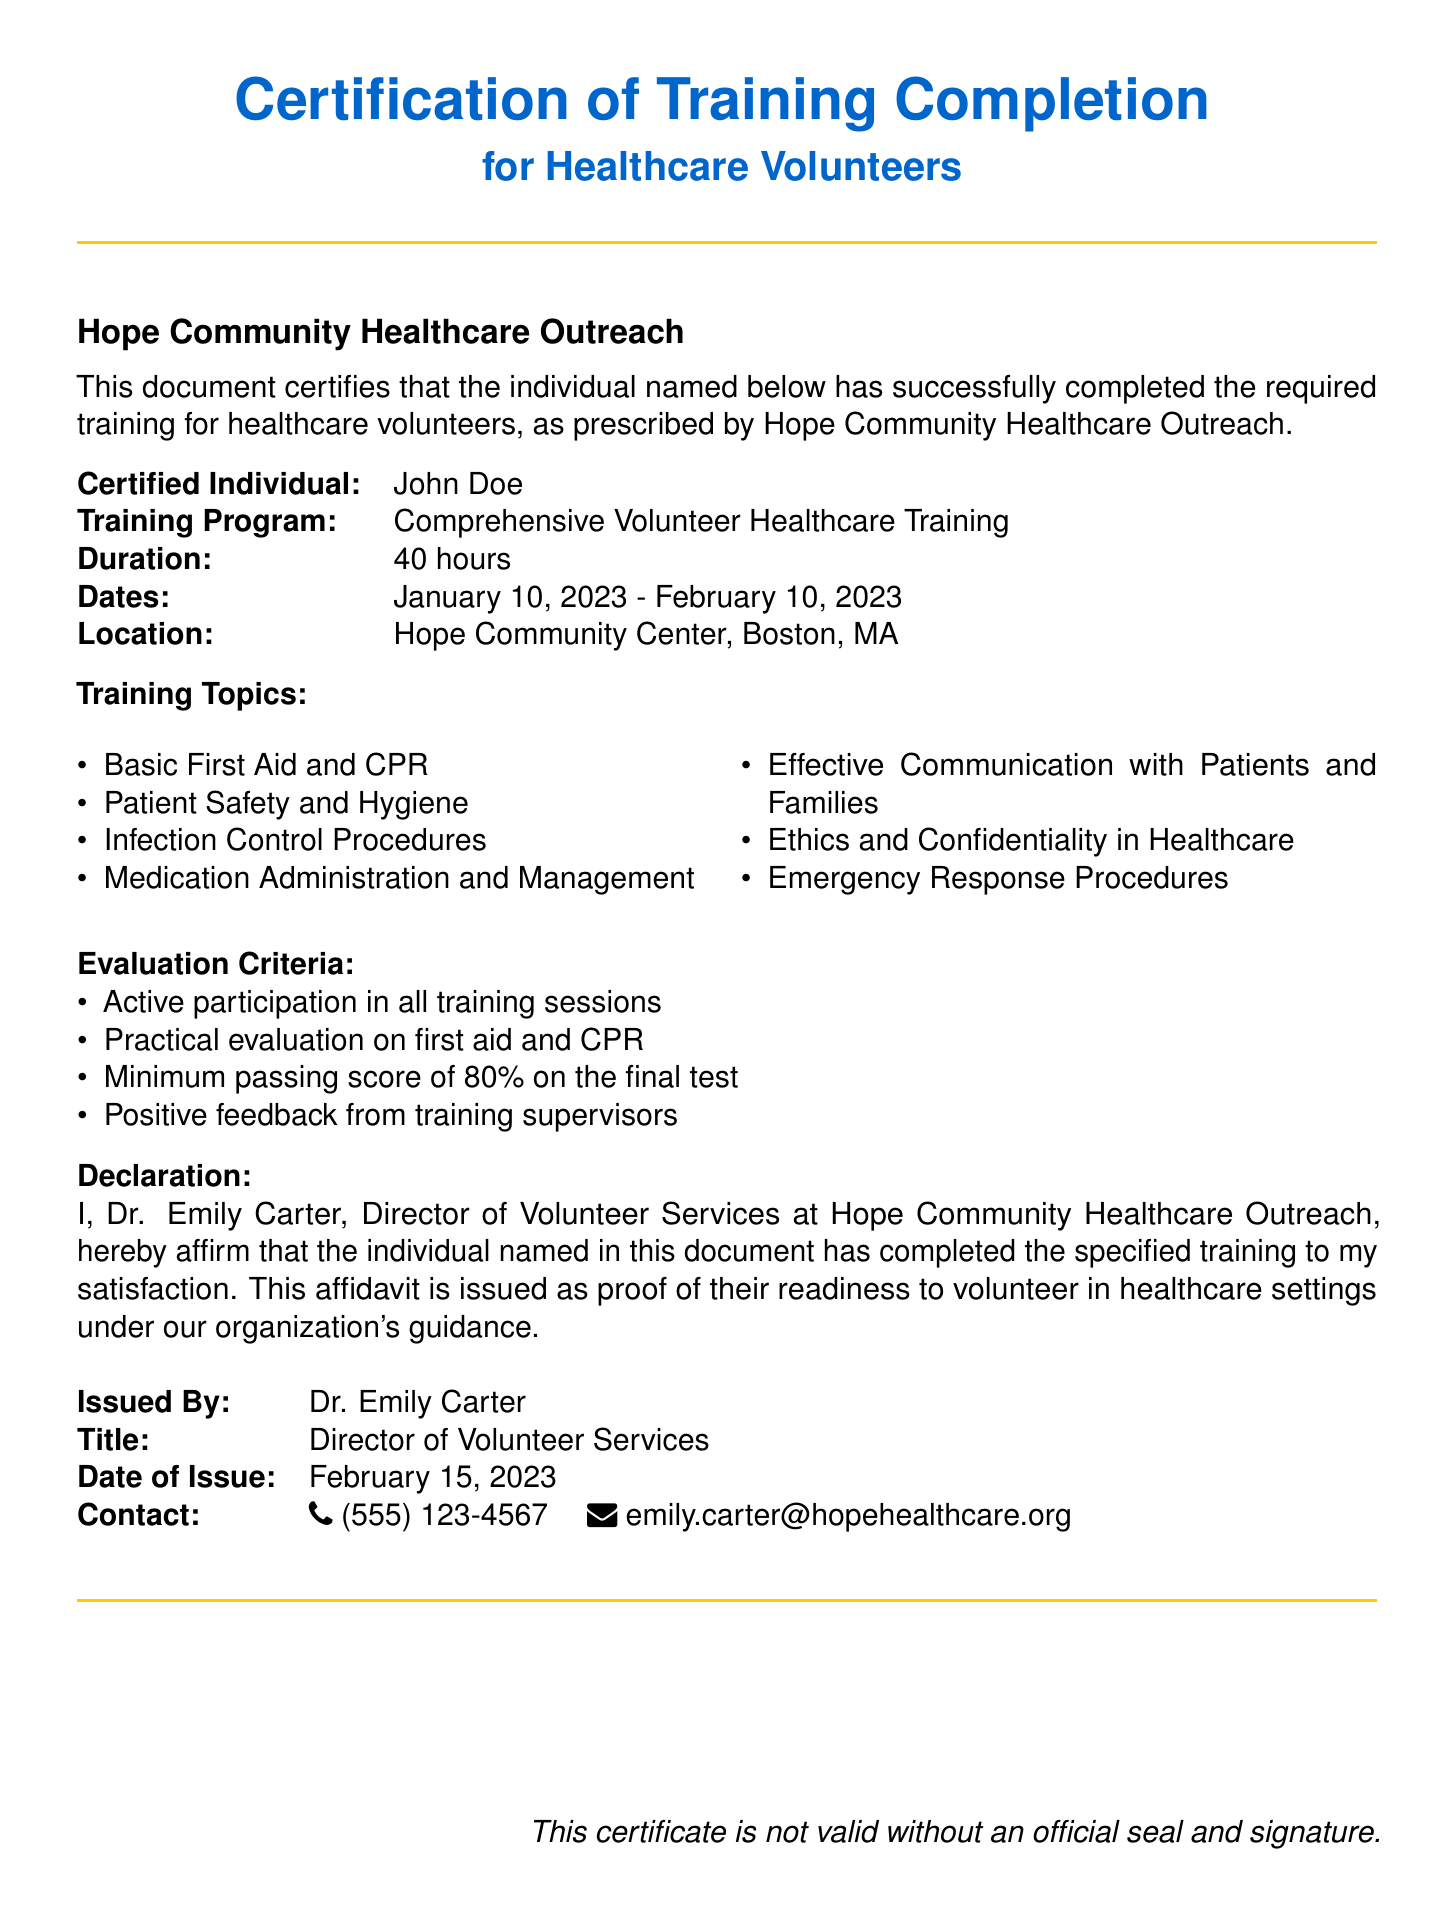What is the name of the certified individual? The certified individual is the person who completed the training, mentioned in the document as "John Doe."
Answer: John Doe What is the duration of the training program? The duration refers to the total time spent in the training, which is specified as "40 hours."
Answer: 40 hours What were the training dates? The training dates indicate when the training took place, shown as "January 10, 2023 - February 10, 2023."
Answer: January 10, 2023 - February 10, 2023 Who issued the certificate? The issuer is the person named in the document who declared the training completion, referred to as "Dr. Emily Carter."
Answer: Dr. Emily Carter What is the minimum passing score on the final test? This score indicates the required percentage for passing the evaluation, noted as "80%."
Answer: 80% Why is Dr. Emily Carter’s title significant in this document? Her title establishes her authority and responsibility in verifying the training completion in the context of the affidavit.
Answer: Director of Volunteer Services What is mentioned as a requirement for the validity of the certificate? The validity requirement specifies the necessary affirmation for the certificate, noted as "an official seal and signature."
Answer: an official seal and signature Which location hosted the training sessions? The training location is where the volunteer training occurred, explicitly mentioned as "Hope Community Center, Boston, MA."
Answer: Hope Community Center, Boston, MA What is one of the training topics covered? The document lists various topics covered in the training; one of them is "Basic First Aid and CPR."
Answer: Basic First Aid and CPR 